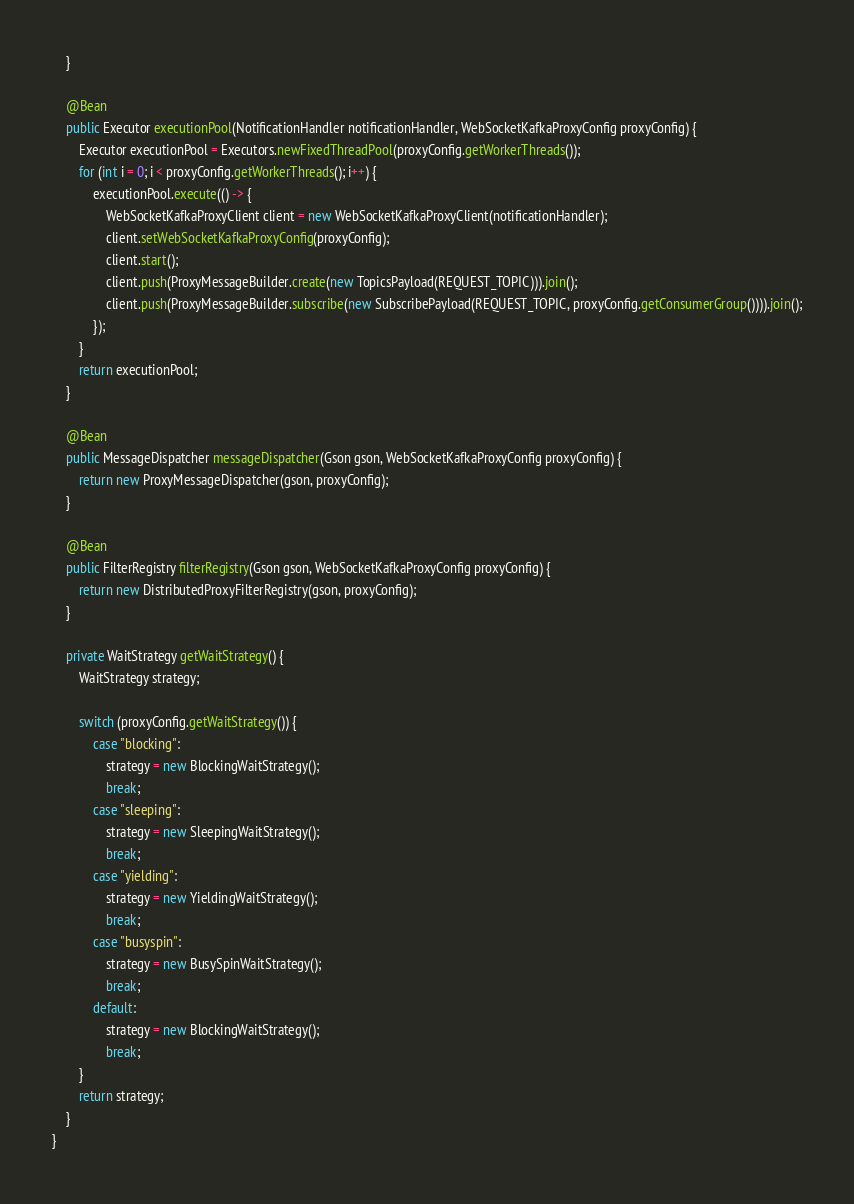<code> <loc_0><loc_0><loc_500><loc_500><_Java_>    }

    @Bean
    public Executor executionPool(NotificationHandler notificationHandler, WebSocketKafkaProxyConfig proxyConfig) {
        Executor executionPool = Executors.newFixedThreadPool(proxyConfig.getWorkerThreads());
        for (int i = 0; i < proxyConfig.getWorkerThreads(); i++) {
            executionPool.execute(() -> {
                WebSocketKafkaProxyClient client = new WebSocketKafkaProxyClient(notificationHandler);
                client.setWebSocketKafkaProxyConfig(proxyConfig);
                client.start();
                client.push(ProxyMessageBuilder.create(new TopicsPayload(REQUEST_TOPIC))).join();
                client.push(ProxyMessageBuilder.subscribe(new SubscribePayload(REQUEST_TOPIC, proxyConfig.getConsumerGroup()))).join();
            });
        }
        return executionPool;
    }

    @Bean
    public MessageDispatcher messageDispatcher(Gson gson, WebSocketKafkaProxyConfig proxyConfig) {
        return new ProxyMessageDispatcher(gson, proxyConfig);
    }

    @Bean
    public FilterRegistry filterRegistry(Gson gson, WebSocketKafkaProxyConfig proxyConfig) {
        return new DistributedProxyFilterRegistry(gson, proxyConfig);
    }

    private WaitStrategy getWaitStrategy() {
        WaitStrategy strategy;

        switch (proxyConfig.getWaitStrategy()) {
            case "blocking":
                strategy = new BlockingWaitStrategy();
                break;
            case "sleeping":
                strategy = new SleepingWaitStrategy();
                break;
            case "yielding":
                strategy = new YieldingWaitStrategy();
                break;
            case "busyspin":
                strategy = new BusySpinWaitStrategy();
                break;
            default:
                strategy = new BlockingWaitStrategy();
                break;
        }
        return strategy;
    }
}
</code> 